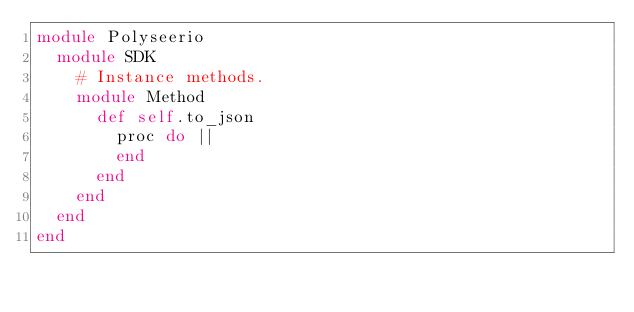<code> <loc_0><loc_0><loc_500><loc_500><_Ruby_>module Polyseerio
  module SDK
    # Instance methods.
    module Method
      def self.to_json
        proc do ||
        end
      end
    end
  end
end
</code> 